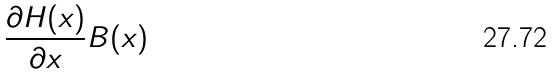Convert formula to latex. <formula><loc_0><loc_0><loc_500><loc_500>\frac { \partial H ( x ) } { \partial x } B ( x )</formula> 